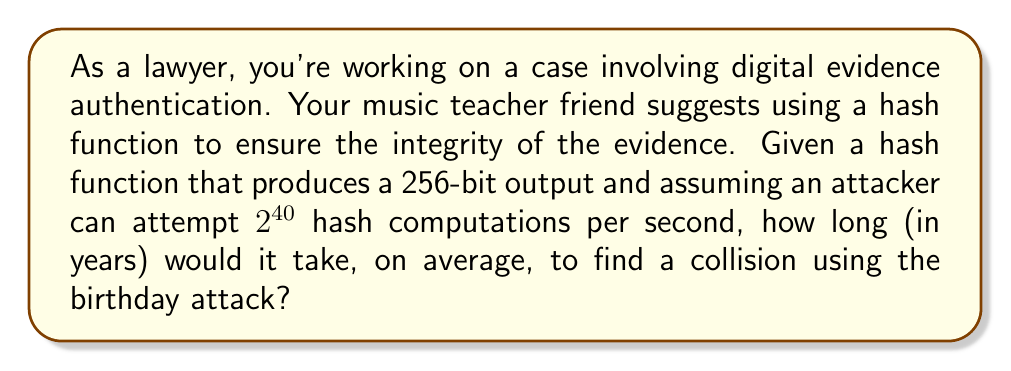Provide a solution to this math problem. Let's approach this step-by-step:

1) The birthday attack is based on the birthday paradox, which states that in a group of 23 people, there's a 50% chance that two people share the same birthday.

2) For a hash function with an n-bit output, the number of hash attempts needed to find a collision with 50% probability is approximately $\sqrt{2^n}$.

3) In this case, we have a 256-bit hash function, so $n = 256$.

4) The number of attempts needed is:

   $$\sqrt{2^{256}} = 2^{128}$$

5) The attacker can make $2^{40}$ attempts per second.

6) The time needed in seconds is:

   $$\frac{2^{128}}{2^{40}} = 2^{88}$$

7) To convert this to years, we need to divide by the number of seconds in a year:

   $$\text{Time in years} = \frac{2^{88}}{60 \times 60 \times 24 \times 365.25}$$

8) Simplifying:

   $$\text{Time in years} \approx \frac{2^{88}}{31,557,600} \approx 9.84 \times 10^{18}$$

This is approximately 9.84 quintillion years.
Answer: $9.84 \times 10^{18}$ years 